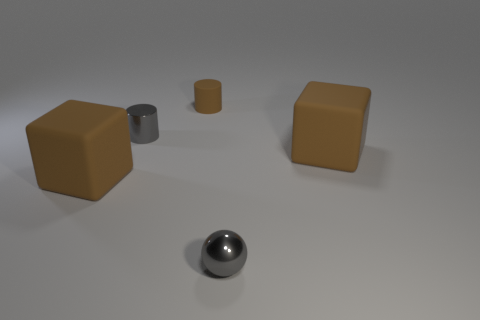Add 1 brown objects. How many objects exist? 6 Subtract all brown cylinders. How many cylinders are left? 1 Subtract all cylinders. How many objects are left? 3 Subtract all green cubes. Subtract all purple spheres. How many cubes are left? 2 Subtract all cyan cubes. How many gray cylinders are left? 1 Subtract all small brown objects. Subtract all brown cubes. How many objects are left? 2 Add 2 tiny shiny cylinders. How many tiny shiny cylinders are left? 3 Add 2 small blue blocks. How many small blue blocks exist? 2 Subtract 0 gray blocks. How many objects are left? 5 Subtract 1 spheres. How many spheres are left? 0 